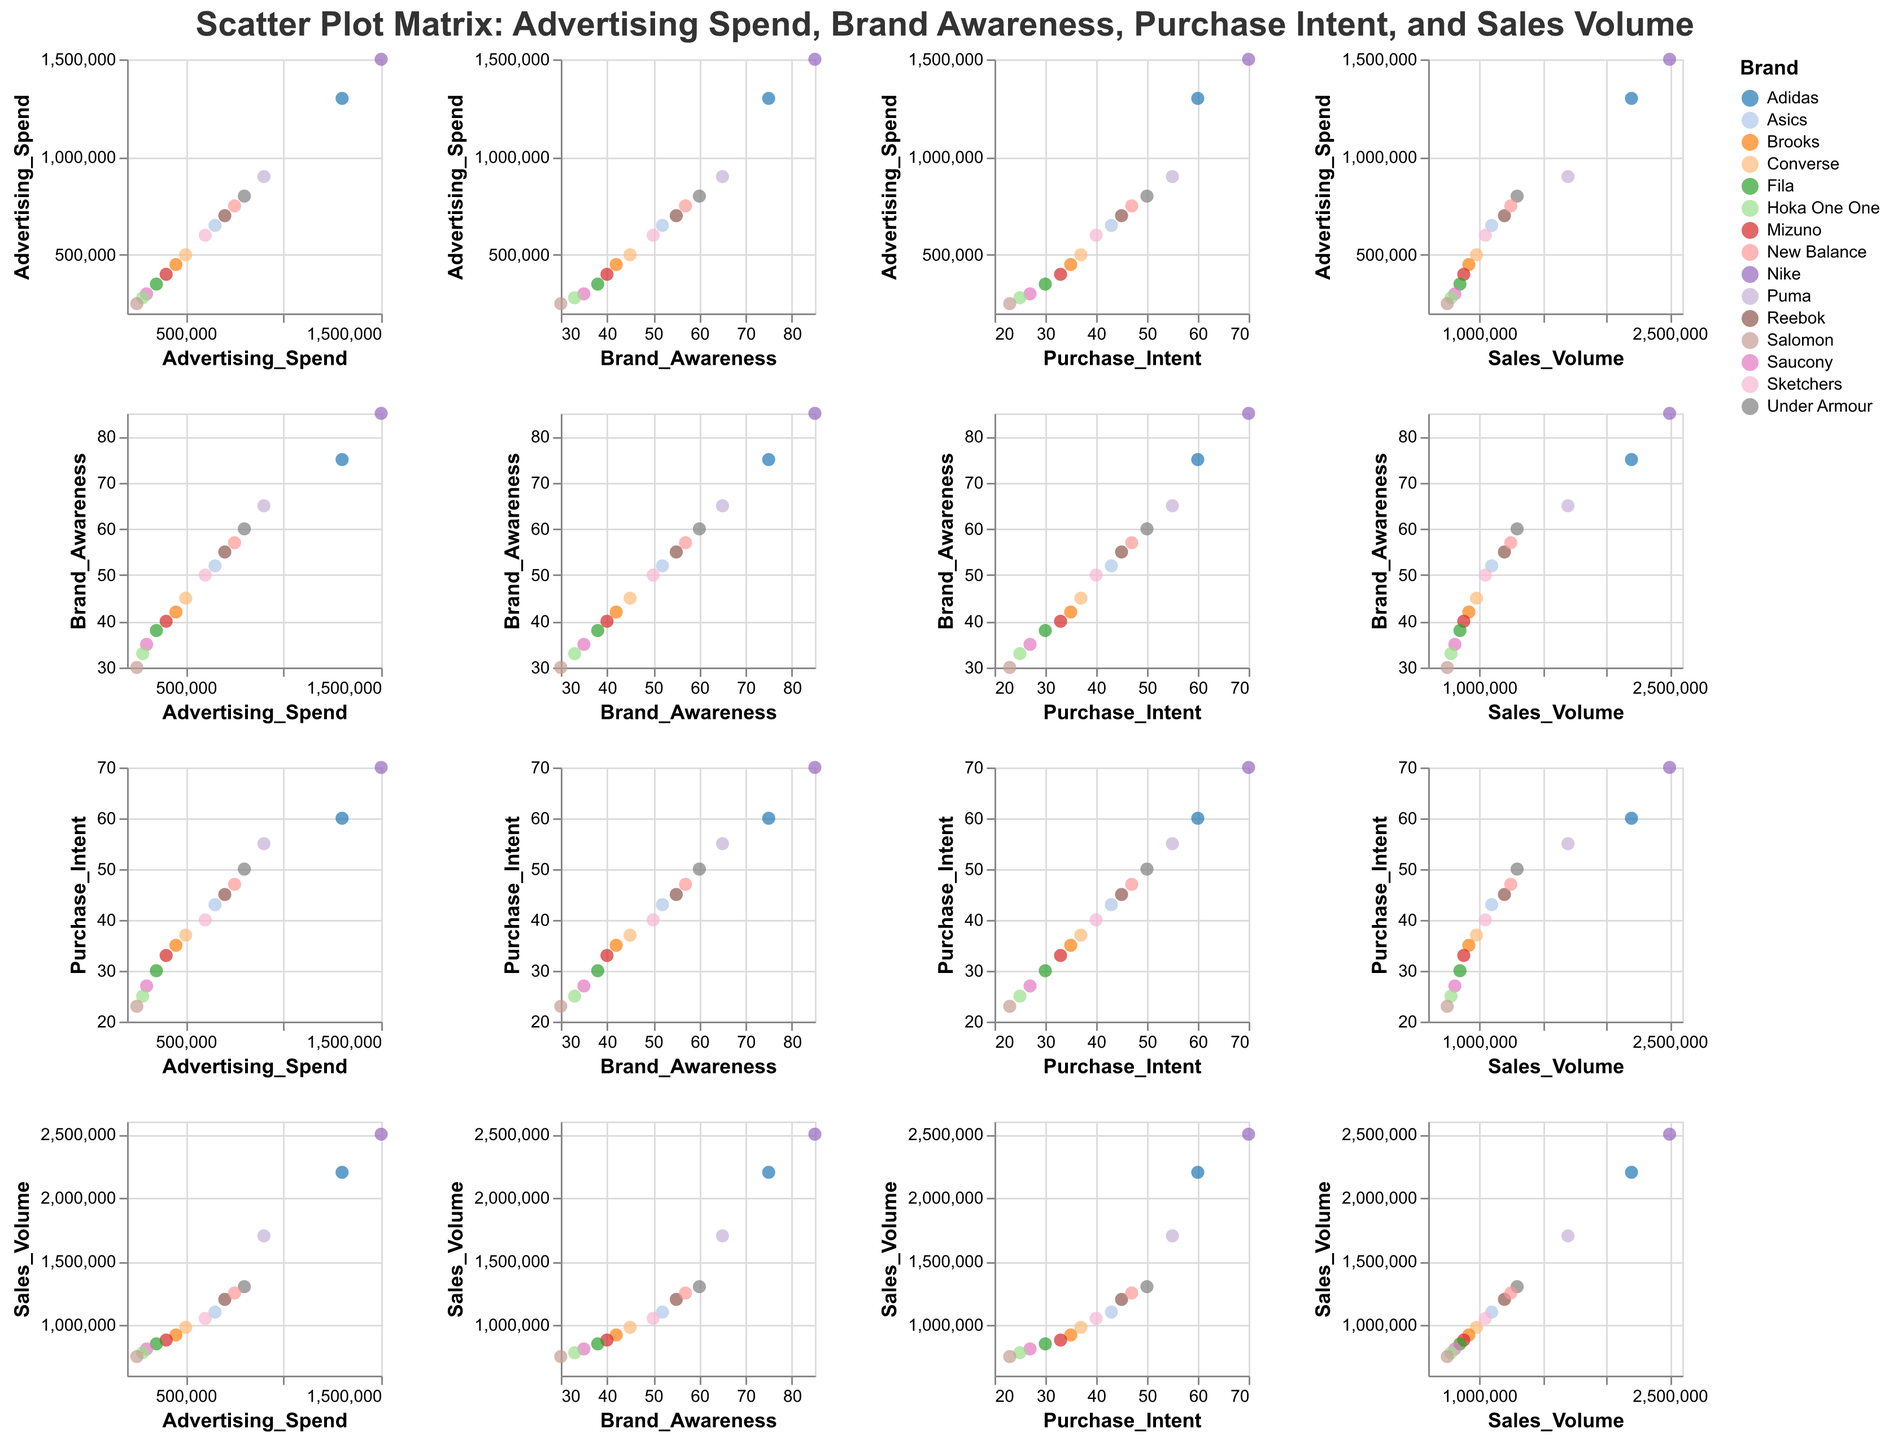What is the title of the scatter plot matrix? The title appears at the top of the figure. It reads "Scatter Plot Matrix: Advertising Spend, Brand Awareness, Purchase Intent, and Sales Volume".
Answer: Scatter Plot Matrix: Advertising Spend, Brand Awareness, Purchase Intent, and Sales Volume How many brands are represented in the scatter plot matrix? By counting the number of unique points on the tooltip linked with each brand name, we find that there are 15 different brands represented.
Answer: 15 Which brand has the highest advertising spend? By looking at the points along the Advertising Spend axis, we note that Nike has the highest spend at 1,500,000 dollars.
Answer: Nike What is the relationship between brand awareness and purchase intent? Examining the scatter plots with Brand Awareness and Purchase Intent on the axes, a positive correlation is seen indicating that higher brand awareness is associated with higher purchase intent.
Answer: Positive correlation Which brand has the highest sales volume? Looking at the Sales Volume axis, the brand with the highest point is Nike with a sales volume of 2,500,000.
Answer: Nike Is there a relationship between advertising spend and sales volume? By examining the scatter plot matrix, comparing the Advertising Spend axis with Sales Volume, a positive correlation is visible indicating more advertising spend is associated with higher sales volume.
Answer: Positive correlation Which brand is associated with a purchase intent of 43? Pointing the cursor at the scatter points that map Purchase Intent, the tooltip reveals Asics has a purchase intent value of 43.
Answer: Asics What is the difference in sales volume between Nike and Adidas? Nike has a sales volume of 2,500,000, and Adidas has 2,200,000. The difference is 2500000 - 2200000 = 300000.
Answer: 300000 Are there any brands with a brand awareness below 40? Looking at the Brand Awareness axis, the brands with values below 40 are Mizuno, Fila, Saucony, Hoka One One, and Salomon.
Answer: Yes What is the average purchase intent for brands with an advertising spend over 1,000,000? Nike (70) and Adidas (60) have advertising spends over 1,000,000. The average is (70 + 60) / 2 = 65.
Answer: 65 